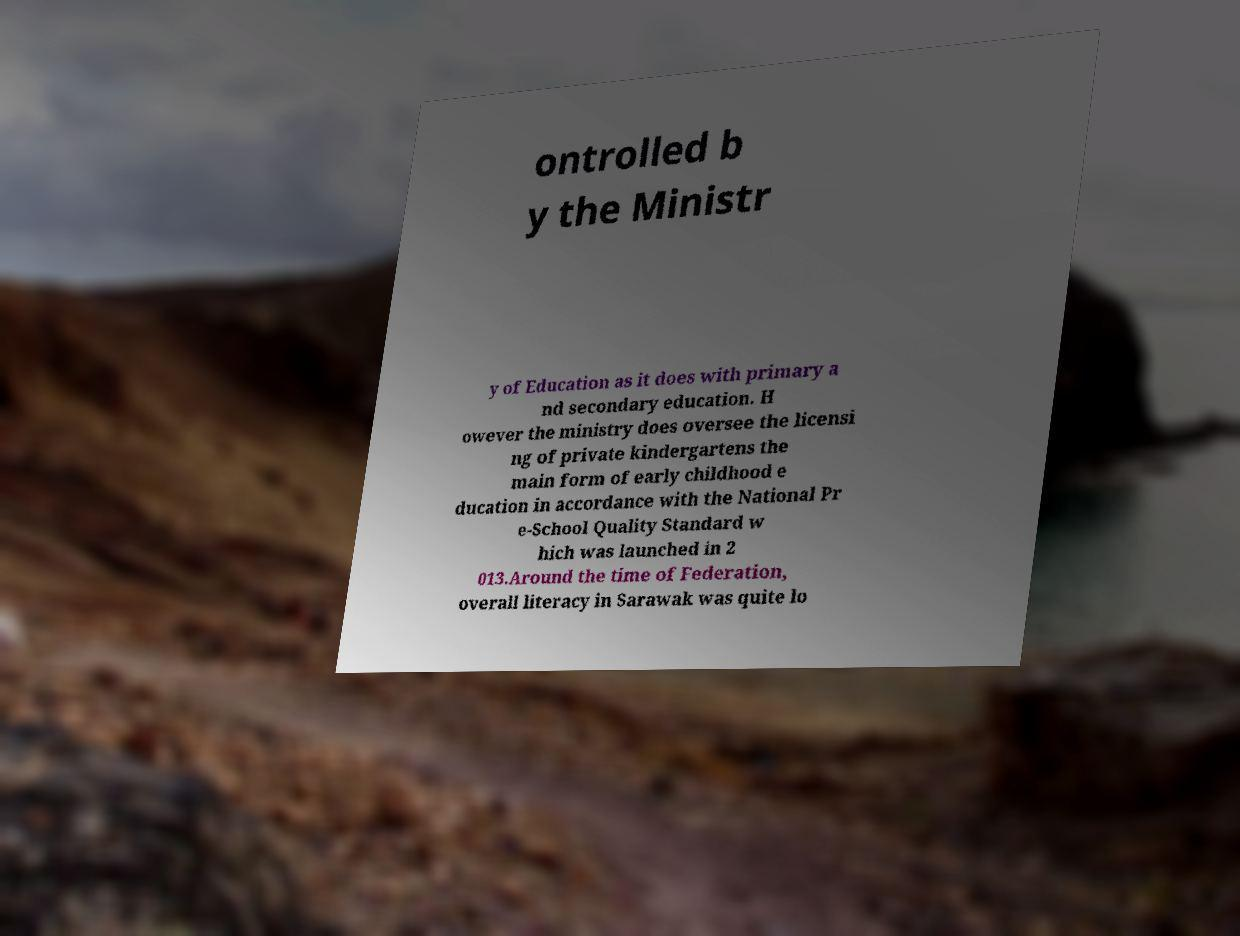Can you accurately transcribe the text from the provided image for me? ontrolled b y the Ministr y of Education as it does with primary a nd secondary education. H owever the ministry does oversee the licensi ng of private kindergartens the main form of early childhood e ducation in accordance with the National Pr e-School Quality Standard w hich was launched in 2 013.Around the time of Federation, overall literacy in Sarawak was quite lo 